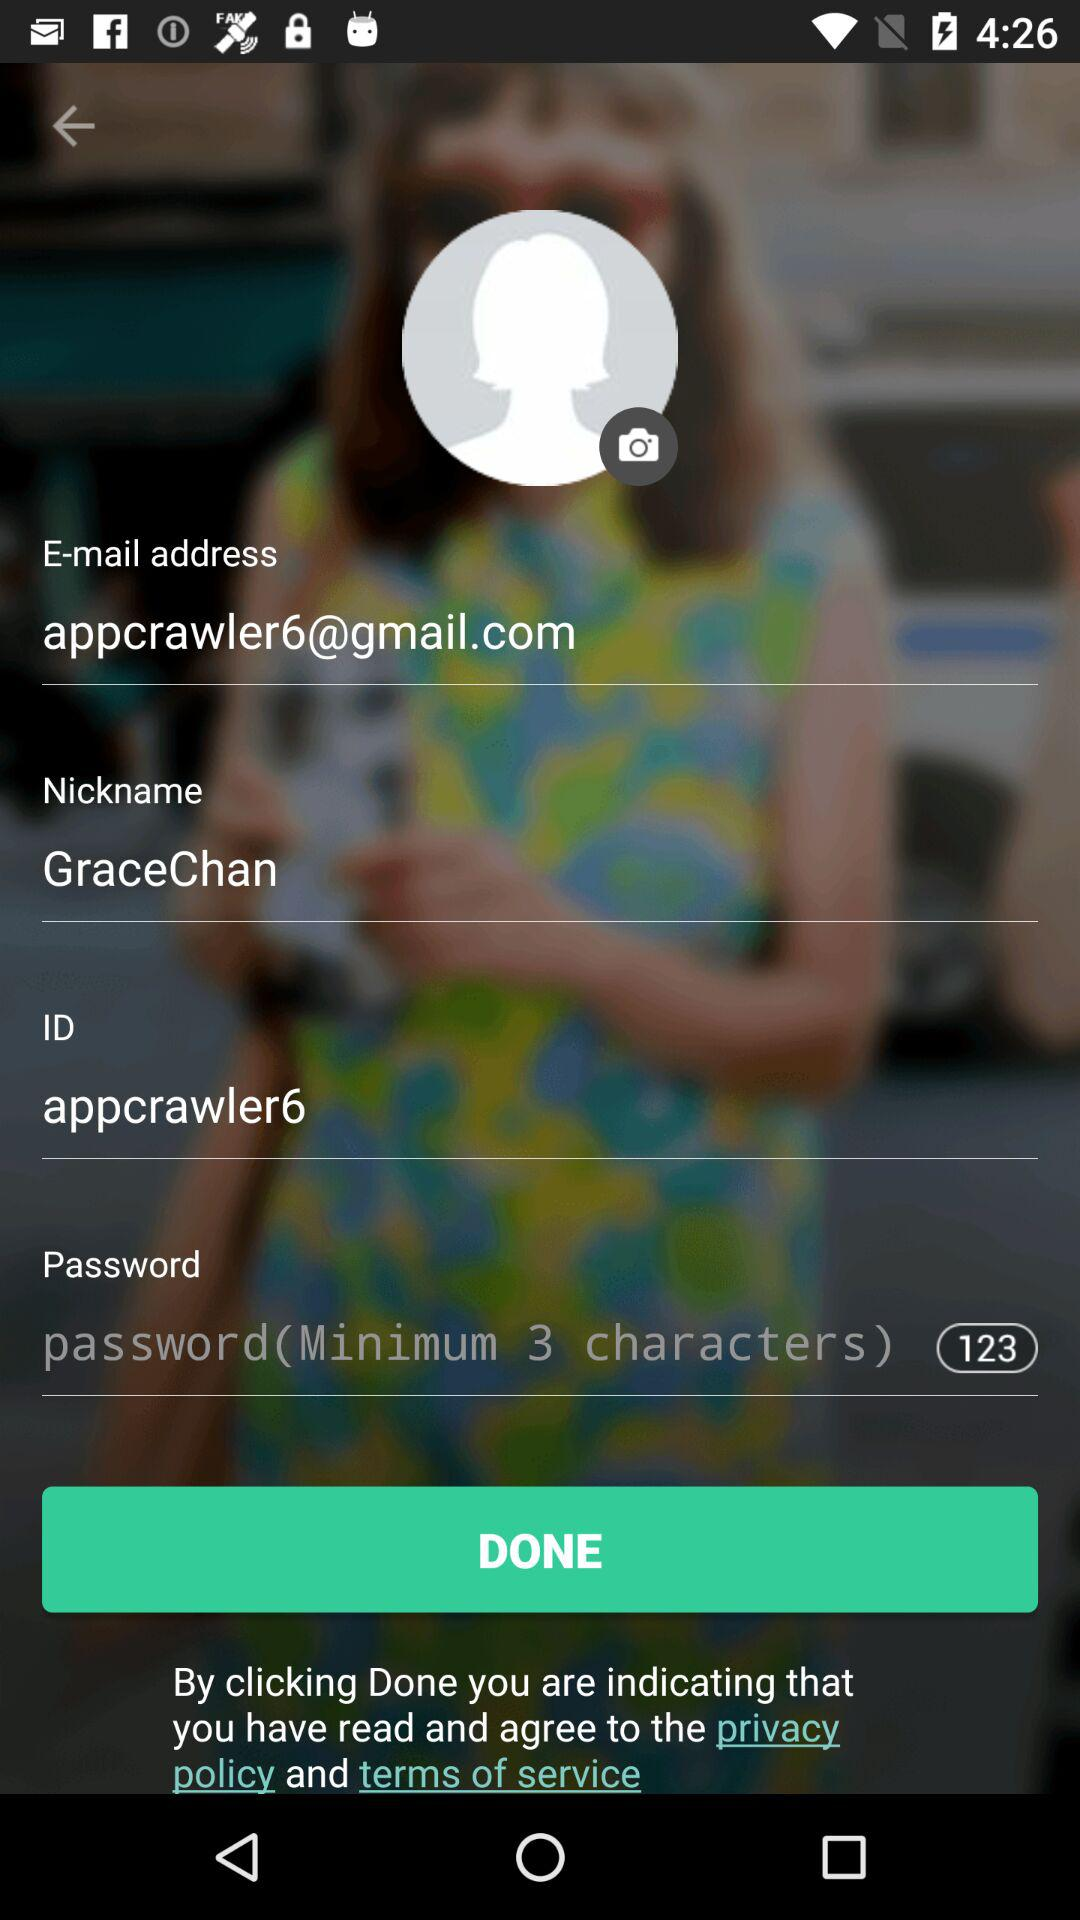What's the nickname? The nickname is Grace Chan. 